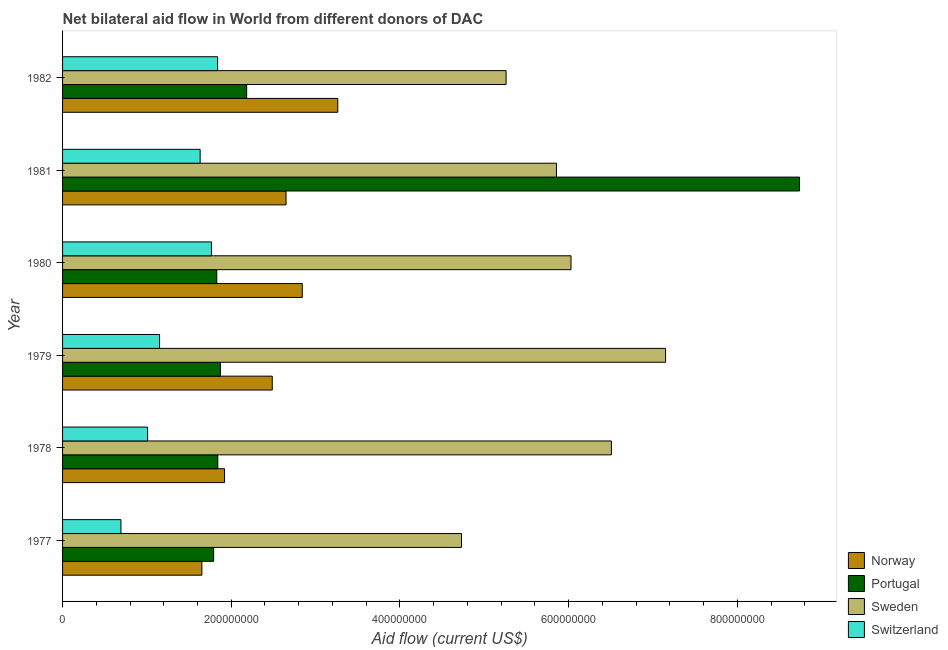How many groups of bars are there?
Ensure brevity in your answer.  6. Are the number of bars per tick equal to the number of legend labels?
Offer a terse response. Yes. Are the number of bars on each tick of the Y-axis equal?
Provide a succinct answer. Yes. How many bars are there on the 3rd tick from the top?
Keep it short and to the point. 4. How many bars are there on the 5th tick from the bottom?
Give a very brief answer. 4. In how many cases, is the number of bars for a given year not equal to the number of legend labels?
Keep it short and to the point. 0. What is the amount of aid given by portugal in 1982?
Offer a very short reply. 2.18e+08. Across all years, what is the maximum amount of aid given by switzerland?
Provide a succinct answer. 1.84e+08. Across all years, what is the minimum amount of aid given by norway?
Your answer should be very brief. 1.65e+08. In which year was the amount of aid given by portugal maximum?
Provide a succinct answer. 1981. What is the total amount of aid given by switzerland in the graph?
Your response must be concise. 8.09e+08. What is the difference between the amount of aid given by switzerland in 1978 and that in 1982?
Offer a very short reply. -8.30e+07. What is the difference between the amount of aid given by norway in 1982 and the amount of aid given by portugal in 1978?
Provide a succinct answer. 1.42e+08. What is the average amount of aid given by sweden per year?
Provide a short and direct response. 5.92e+08. In the year 1982, what is the difference between the amount of aid given by portugal and amount of aid given by norway?
Your response must be concise. -1.08e+08. What is the ratio of the amount of aid given by sweden in 1979 to that in 1980?
Your response must be concise. 1.19. What is the difference between the highest and the second highest amount of aid given by norway?
Ensure brevity in your answer.  4.21e+07. What is the difference between the highest and the lowest amount of aid given by sweden?
Provide a short and direct response. 2.42e+08. In how many years, is the amount of aid given by switzerland greater than the average amount of aid given by switzerland taken over all years?
Your response must be concise. 3. Is the sum of the amount of aid given by portugal in 1980 and 1981 greater than the maximum amount of aid given by sweden across all years?
Your answer should be very brief. Yes. Is it the case that in every year, the sum of the amount of aid given by switzerland and amount of aid given by norway is greater than the sum of amount of aid given by portugal and amount of aid given by sweden?
Offer a terse response. No. What does the 3rd bar from the top in 1977 represents?
Provide a succinct answer. Portugal. What does the 2nd bar from the bottom in 1978 represents?
Provide a short and direct response. Portugal. Is it the case that in every year, the sum of the amount of aid given by norway and amount of aid given by portugal is greater than the amount of aid given by sweden?
Give a very brief answer. No. How many years are there in the graph?
Your response must be concise. 6. What is the difference between two consecutive major ticks on the X-axis?
Your response must be concise. 2.00e+08. Does the graph contain grids?
Give a very brief answer. No. Where does the legend appear in the graph?
Your response must be concise. Bottom right. What is the title of the graph?
Ensure brevity in your answer.  Net bilateral aid flow in World from different donors of DAC. What is the label or title of the X-axis?
Keep it short and to the point. Aid flow (current US$). What is the label or title of the Y-axis?
Keep it short and to the point. Year. What is the Aid flow (current US$) in Norway in 1977?
Your answer should be very brief. 1.65e+08. What is the Aid flow (current US$) in Portugal in 1977?
Offer a terse response. 1.79e+08. What is the Aid flow (current US$) of Sweden in 1977?
Offer a terse response. 4.73e+08. What is the Aid flow (current US$) in Switzerland in 1977?
Offer a very short reply. 6.92e+07. What is the Aid flow (current US$) of Norway in 1978?
Offer a terse response. 1.92e+08. What is the Aid flow (current US$) of Portugal in 1978?
Offer a very short reply. 1.84e+08. What is the Aid flow (current US$) of Sweden in 1978?
Your answer should be very brief. 6.51e+08. What is the Aid flow (current US$) of Switzerland in 1978?
Offer a terse response. 1.01e+08. What is the Aid flow (current US$) in Norway in 1979?
Make the answer very short. 2.49e+08. What is the Aid flow (current US$) in Portugal in 1979?
Give a very brief answer. 1.87e+08. What is the Aid flow (current US$) in Sweden in 1979?
Offer a very short reply. 7.15e+08. What is the Aid flow (current US$) in Switzerland in 1979?
Make the answer very short. 1.15e+08. What is the Aid flow (current US$) of Norway in 1980?
Offer a very short reply. 2.84e+08. What is the Aid flow (current US$) of Portugal in 1980?
Give a very brief answer. 1.83e+08. What is the Aid flow (current US$) in Sweden in 1980?
Your response must be concise. 6.03e+08. What is the Aid flow (current US$) in Switzerland in 1980?
Keep it short and to the point. 1.77e+08. What is the Aid flow (current US$) of Norway in 1981?
Give a very brief answer. 2.65e+08. What is the Aid flow (current US$) of Portugal in 1981?
Offer a very short reply. 8.74e+08. What is the Aid flow (current US$) of Sweden in 1981?
Provide a succinct answer. 5.86e+08. What is the Aid flow (current US$) of Switzerland in 1981?
Offer a very short reply. 1.63e+08. What is the Aid flow (current US$) in Norway in 1982?
Give a very brief answer. 3.26e+08. What is the Aid flow (current US$) of Portugal in 1982?
Your response must be concise. 2.18e+08. What is the Aid flow (current US$) of Sweden in 1982?
Your answer should be very brief. 5.26e+08. What is the Aid flow (current US$) in Switzerland in 1982?
Your answer should be very brief. 1.84e+08. Across all years, what is the maximum Aid flow (current US$) in Norway?
Your answer should be compact. 3.26e+08. Across all years, what is the maximum Aid flow (current US$) in Portugal?
Your response must be concise. 8.74e+08. Across all years, what is the maximum Aid flow (current US$) of Sweden?
Ensure brevity in your answer.  7.15e+08. Across all years, what is the maximum Aid flow (current US$) of Switzerland?
Your answer should be very brief. 1.84e+08. Across all years, what is the minimum Aid flow (current US$) in Norway?
Provide a short and direct response. 1.65e+08. Across all years, what is the minimum Aid flow (current US$) in Portugal?
Provide a succinct answer. 1.79e+08. Across all years, what is the minimum Aid flow (current US$) of Sweden?
Offer a very short reply. 4.73e+08. Across all years, what is the minimum Aid flow (current US$) of Switzerland?
Make the answer very short. 6.92e+07. What is the total Aid flow (current US$) of Norway in the graph?
Your response must be concise. 1.48e+09. What is the total Aid flow (current US$) in Portugal in the graph?
Your answer should be compact. 1.83e+09. What is the total Aid flow (current US$) in Sweden in the graph?
Give a very brief answer. 3.55e+09. What is the total Aid flow (current US$) in Switzerland in the graph?
Keep it short and to the point. 8.09e+08. What is the difference between the Aid flow (current US$) of Norway in 1977 and that in 1978?
Provide a succinct answer. -2.69e+07. What is the difference between the Aid flow (current US$) in Portugal in 1977 and that in 1978?
Make the answer very short. -4.93e+06. What is the difference between the Aid flow (current US$) in Sweden in 1977 and that in 1978?
Offer a terse response. -1.78e+08. What is the difference between the Aid flow (current US$) in Switzerland in 1977 and that in 1978?
Your answer should be very brief. -3.16e+07. What is the difference between the Aid flow (current US$) in Norway in 1977 and that in 1979?
Your answer should be very brief. -8.34e+07. What is the difference between the Aid flow (current US$) in Portugal in 1977 and that in 1979?
Offer a terse response. -8.00e+06. What is the difference between the Aid flow (current US$) in Sweden in 1977 and that in 1979?
Give a very brief answer. -2.42e+08. What is the difference between the Aid flow (current US$) in Switzerland in 1977 and that in 1979?
Ensure brevity in your answer.  -4.58e+07. What is the difference between the Aid flow (current US$) in Norway in 1977 and that in 1980?
Your answer should be very brief. -1.19e+08. What is the difference between the Aid flow (current US$) in Portugal in 1977 and that in 1980?
Provide a succinct answer. -3.70e+06. What is the difference between the Aid flow (current US$) of Sweden in 1977 and that in 1980?
Offer a very short reply. -1.30e+08. What is the difference between the Aid flow (current US$) of Switzerland in 1977 and that in 1980?
Offer a very short reply. -1.07e+08. What is the difference between the Aid flow (current US$) in Norway in 1977 and that in 1981?
Provide a short and direct response. -9.98e+07. What is the difference between the Aid flow (current US$) of Portugal in 1977 and that in 1981?
Offer a terse response. -6.95e+08. What is the difference between the Aid flow (current US$) in Sweden in 1977 and that in 1981?
Your response must be concise. -1.13e+08. What is the difference between the Aid flow (current US$) in Switzerland in 1977 and that in 1981?
Make the answer very short. -9.39e+07. What is the difference between the Aid flow (current US$) of Norway in 1977 and that in 1982?
Offer a terse response. -1.61e+08. What is the difference between the Aid flow (current US$) of Portugal in 1977 and that in 1982?
Ensure brevity in your answer.  -3.92e+07. What is the difference between the Aid flow (current US$) of Sweden in 1977 and that in 1982?
Offer a very short reply. -5.29e+07. What is the difference between the Aid flow (current US$) in Switzerland in 1977 and that in 1982?
Provide a short and direct response. -1.15e+08. What is the difference between the Aid flow (current US$) of Norway in 1978 and that in 1979?
Ensure brevity in your answer.  -5.66e+07. What is the difference between the Aid flow (current US$) in Portugal in 1978 and that in 1979?
Your answer should be very brief. -3.07e+06. What is the difference between the Aid flow (current US$) of Sweden in 1978 and that in 1979?
Ensure brevity in your answer.  -6.43e+07. What is the difference between the Aid flow (current US$) of Switzerland in 1978 and that in 1979?
Your answer should be compact. -1.42e+07. What is the difference between the Aid flow (current US$) in Norway in 1978 and that in 1980?
Your response must be concise. -9.22e+07. What is the difference between the Aid flow (current US$) of Portugal in 1978 and that in 1980?
Offer a terse response. 1.23e+06. What is the difference between the Aid flow (current US$) in Sweden in 1978 and that in 1980?
Your answer should be very brief. 4.79e+07. What is the difference between the Aid flow (current US$) of Switzerland in 1978 and that in 1980?
Your answer should be compact. -7.57e+07. What is the difference between the Aid flow (current US$) in Norway in 1978 and that in 1981?
Keep it short and to the point. -7.29e+07. What is the difference between the Aid flow (current US$) of Portugal in 1978 and that in 1981?
Your answer should be compact. -6.90e+08. What is the difference between the Aid flow (current US$) in Sweden in 1978 and that in 1981?
Give a very brief answer. 6.51e+07. What is the difference between the Aid flow (current US$) in Switzerland in 1978 and that in 1981?
Ensure brevity in your answer.  -6.23e+07. What is the difference between the Aid flow (current US$) of Norway in 1978 and that in 1982?
Offer a very short reply. -1.34e+08. What is the difference between the Aid flow (current US$) in Portugal in 1978 and that in 1982?
Your response must be concise. -3.42e+07. What is the difference between the Aid flow (current US$) in Sweden in 1978 and that in 1982?
Ensure brevity in your answer.  1.25e+08. What is the difference between the Aid flow (current US$) in Switzerland in 1978 and that in 1982?
Give a very brief answer. -8.30e+07. What is the difference between the Aid flow (current US$) of Norway in 1979 and that in 1980?
Offer a terse response. -3.56e+07. What is the difference between the Aid flow (current US$) of Portugal in 1979 and that in 1980?
Make the answer very short. 4.30e+06. What is the difference between the Aid flow (current US$) of Sweden in 1979 and that in 1980?
Provide a succinct answer. 1.12e+08. What is the difference between the Aid flow (current US$) of Switzerland in 1979 and that in 1980?
Ensure brevity in your answer.  -6.15e+07. What is the difference between the Aid flow (current US$) of Norway in 1979 and that in 1981?
Keep it short and to the point. -1.63e+07. What is the difference between the Aid flow (current US$) of Portugal in 1979 and that in 1981?
Offer a very short reply. -6.87e+08. What is the difference between the Aid flow (current US$) of Sweden in 1979 and that in 1981?
Offer a terse response. 1.29e+08. What is the difference between the Aid flow (current US$) of Switzerland in 1979 and that in 1981?
Provide a succinct answer. -4.81e+07. What is the difference between the Aid flow (current US$) of Norway in 1979 and that in 1982?
Offer a terse response. -7.77e+07. What is the difference between the Aid flow (current US$) of Portugal in 1979 and that in 1982?
Provide a short and direct response. -3.12e+07. What is the difference between the Aid flow (current US$) in Sweden in 1979 and that in 1982?
Ensure brevity in your answer.  1.89e+08. What is the difference between the Aid flow (current US$) of Switzerland in 1979 and that in 1982?
Offer a terse response. -6.88e+07. What is the difference between the Aid flow (current US$) of Norway in 1980 and that in 1981?
Provide a succinct answer. 1.93e+07. What is the difference between the Aid flow (current US$) in Portugal in 1980 and that in 1981?
Provide a succinct answer. -6.91e+08. What is the difference between the Aid flow (current US$) in Sweden in 1980 and that in 1981?
Ensure brevity in your answer.  1.72e+07. What is the difference between the Aid flow (current US$) in Switzerland in 1980 and that in 1981?
Offer a terse response. 1.34e+07. What is the difference between the Aid flow (current US$) in Norway in 1980 and that in 1982?
Ensure brevity in your answer.  -4.21e+07. What is the difference between the Aid flow (current US$) of Portugal in 1980 and that in 1982?
Make the answer very short. -3.54e+07. What is the difference between the Aid flow (current US$) in Sweden in 1980 and that in 1982?
Your answer should be compact. 7.70e+07. What is the difference between the Aid flow (current US$) in Switzerland in 1980 and that in 1982?
Your answer should be very brief. -7.31e+06. What is the difference between the Aid flow (current US$) in Norway in 1981 and that in 1982?
Offer a very short reply. -6.13e+07. What is the difference between the Aid flow (current US$) of Portugal in 1981 and that in 1982?
Your response must be concise. 6.56e+08. What is the difference between the Aid flow (current US$) in Sweden in 1981 and that in 1982?
Your answer should be very brief. 5.97e+07. What is the difference between the Aid flow (current US$) in Switzerland in 1981 and that in 1982?
Make the answer very short. -2.07e+07. What is the difference between the Aid flow (current US$) in Norway in 1977 and the Aid flow (current US$) in Portugal in 1978?
Your answer should be compact. -1.89e+07. What is the difference between the Aid flow (current US$) of Norway in 1977 and the Aid flow (current US$) of Sweden in 1978?
Your response must be concise. -4.86e+08. What is the difference between the Aid flow (current US$) in Norway in 1977 and the Aid flow (current US$) in Switzerland in 1978?
Your answer should be very brief. 6.44e+07. What is the difference between the Aid flow (current US$) of Portugal in 1977 and the Aid flow (current US$) of Sweden in 1978?
Offer a terse response. -4.72e+08. What is the difference between the Aid flow (current US$) in Portugal in 1977 and the Aid flow (current US$) in Switzerland in 1978?
Make the answer very short. 7.83e+07. What is the difference between the Aid flow (current US$) of Sweden in 1977 and the Aid flow (current US$) of Switzerland in 1978?
Offer a very short reply. 3.72e+08. What is the difference between the Aid flow (current US$) of Norway in 1977 and the Aid flow (current US$) of Portugal in 1979?
Ensure brevity in your answer.  -2.20e+07. What is the difference between the Aid flow (current US$) in Norway in 1977 and the Aid flow (current US$) in Sweden in 1979?
Offer a terse response. -5.50e+08. What is the difference between the Aid flow (current US$) in Norway in 1977 and the Aid flow (current US$) in Switzerland in 1979?
Your answer should be compact. 5.02e+07. What is the difference between the Aid flow (current US$) in Portugal in 1977 and the Aid flow (current US$) in Sweden in 1979?
Keep it short and to the point. -5.36e+08. What is the difference between the Aid flow (current US$) of Portugal in 1977 and the Aid flow (current US$) of Switzerland in 1979?
Your response must be concise. 6.41e+07. What is the difference between the Aid flow (current US$) in Sweden in 1977 and the Aid flow (current US$) in Switzerland in 1979?
Provide a succinct answer. 3.58e+08. What is the difference between the Aid flow (current US$) of Norway in 1977 and the Aid flow (current US$) of Portugal in 1980?
Provide a succinct answer. -1.76e+07. What is the difference between the Aid flow (current US$) in Norway in 1977 and the Aid flow (current US$) in Sweden in 1980?
Provide a succinct answer. -4.38e+08. What is the difference between the Aid flow (current US$) of Norway in 1977 and the Aid flow (current US$) of Switzerland in 1980?
Your answer should be compact. -1.13e+07. What is the difference between the Aid flow (current US$) of Portugal in 1977 and the Aid flow (current US$) of Sweden in 1980?
Ensure brevity in your answer.  -4.24e+08. What is the difference between the Aid flow (current US$) of Portugal in 1977 and the Aid flow (current US$) of Switzerland in 1980?
Ensure brevity in your answer.  2.63e+06. What is the difference between the Aid flow (current US$) of Sweden in 1977 and the Aid flow (current US$) of Switzerland in 1980?
Provide a succinct answer. 2.97e+08. What is the difference between the Aid flow (current US$) of Norway in 1977 and the Aid flow (current US$) of Portugal in 1981?
Your answer should be very brief. -7.09e+08. What is the difference between the Aid flow (current US$) in Norway in 1977 and the Aid flow (current US$) in Sweden in 1981?
Provide a short and direct response. -4.20e+08. What is the difference between the Aid flow (current US$) of Norway in 1977 and the Aid flow (current US$) of Switzerland in 1981?
Your answer should be very brief. 2.07e+06. What is the difference between the Aid flow (current US$) in Portugal in 1977 and the Aid flow (current US$) in Sweden in 1981?
Make the answer very short. -4.06e+08. What is the difference between the Aid flow (current US$) in Portugal in 1977 and the Aid flow (current US$) in Switzerland in 1981?
Make the answer very short. 1.60e+07. What is the difference between the Aid flow (current US$) in Sweden in 1977 and the Aid flow (current US$) in Switzerland in 1981?
Ensure brevity in your answer.  3.10e+08. What is the difference between the Aid flow (current US$) of Norway in 1977 and the Aid flow (current US$) of Portugal in 1982?
Ensure brevity in your answer.  -5.31e+07. What is the difference between the Aid flow (current US$) of Norway in 1977 and the Aid flow (current US$) of Sweden in 1982?
Offer a very short reply. -3.61e+08. What is the difference between the Aid flow (current US$) of Norway in 1977 and the Aid flow (current US$) of Switzerland in 1982?
Make the answer very short. -1.86e+07. What is the difference between the Aid flow (current US$) of Portugal in 1977 and the Aid flow (current US$) of Sweden in 1982?
Provide a succinct answer. -3.47e+08. What is the difference between the Aid flow (current US$) of Portugal in 1977 and the Aid flow (current US$) of Switzerland in 1982?
Your response must be concise. -4.68e+06. What is the difference between the Aid flow (current US$) of Sweden in 1977 and the Aid flow (current US$) of Switzerland in 1982?
Provide a short and direct response. 2.89e+08. What is the difference between the Aid flow (current US$) of Norway in 1978 and the Aid flow (current US$) of Portugal in 1979?
Your answer should be very brief. 4.91e+06. What is the difference between the Aid flow (current US$) in Norway in 1978 and the Aid flow (current US$) in Sweden in 1979?
Your response must be concise. -5.23e+08. What is the difference between the Aid flow (current US$) in Norway in 1978 and the Aid flow (current US$) in Switzerland in 1979?
Provide a short and direct response. 7.70e+07. What is the difference between the Aid flow (current US$) of Portugal in 1978 and the Aid flow (current US$) of Sweden in 1979?
Provide a succinct answer. -5.31e+08. What is the difference between the Aid flow (current US$) of Portugal in 1978 and the Aid flow (current US$) of Switzerland in 1979?
Give a very brief answer. 6.90e+07. What is the difference between the Aid flow (current US$) in Sweden in 1978 and the Aid flow (current US$) in Switzerland in 1979?
Your answer should be compact. 5.36e+08. What is the difference between the Aid flow (current US$) in Norway in 1978 and the Aid flow (current US$) in Portugal in 1980?
Ensure brevity in your answer.  9.21e+06. What is the difference between the Aid flow (current US$) of Norway in 1978 and the Aid flow (current US$) of Sweden in 1980?
Ensure brevity in your answer.  -4.11e+08. What is the difference between the Aid flow (current US$) in Norway in 1978 and the Aid flow (current US$) in Switzerland in 1980?
Give a very brief answer. 1.55e+07. What is the difference between the Aid flow (current US$) in Portugal in 1978 and the Aid flow (current US$) in Sweden in 1980?
Offer a terse response. -4.19e+08. What is the difference between the Aid flow (current US$) in Portugal in 1978 and the Aid flow (current US$) in Switzerland in 1980?
Offer a very short reply. 7.56e+06. What is the difference between the Aid flow (current US$) of Sweden in 1978 and the Aid flow (current US$) of Switzerland in 1980?
Give a very brief answer. 4.74e+08. What is the difference between the Aid flow (current US$) of Norway in 1978 and the Aid flow (current US$) of Portugal in 1981?
Your response must be concise. -6.82e+08. What is the difference between the Aid flow (current US$) of Norway in 1978 and the Aid flow (current US$) of Sweden in 1981?
Offer a terse response. -3.94e+08. What is the difference between the Aid flow (current US$) of Norway in 1978 and the Aid flow (current US$) of Switzerland in 1981?
Your answer should be compact. 2.89e+07. What is the difference between the Aid flow (current US$) of Portugal in 1978 and the Aid flow (current US$) of Sweden in 1981?
Ensure brevity in your answer.  -4.02e+08. What is the difference between the Aid flow (current US$) in Portugal in 1978 and the Aid flow (current US$) in Switzerland in 1981?
Your answer should be very brief. 2.10e+07. What is the difference between the Aid flow (current US$) in Sweden in 1978 and the Aid flow (current US$) in Switzerland in 1981?
Provide a succinct answer. 4.88e+08. What is the difference between the Aid flow (current US$) of Norway in 1978 and the Aid flow (current US$) of Portugal in 1982?
Offer a very short reply. -2.62e+07. What is the difference between the Aid flow (current US$) of Norway in 1978 and the Aid flow (current US$) of Sweden in 1982?
Keep it short and to the point. -3.34e+08. What is the difference between the Aid flow (current US$) in Norway in 1978 and the Aid flow (current US$) in Switzerland in 1982?
Make the answer very short. 8.23e+06. What is the difference between the Aid flow (current US$) in Portugal in 1978 and the Aid flow (current US$) in Sweden in 1982?
Offer a terse response. -3.42e+08. What is the difference between the Aid flow (current US$) in Portugal in 1978 and the Aid flow (current US$) in Switzerland in 1982?
Provide a short and direct response. 2.50e+05. What is the difference between the Aid flow (current US$) of Sweden in 1978 and the Aid flow (current US$) of Switzerland in 1982?
Provide a succinct answer. 4.67e+08. What is the difference between the Aid flow (current US$) in Norway in 1979 and the Aid flow (current US$) in Portugal in 1980?
Offer a very short reply. 6.58e+07. What is the difference between the Aid flow (current US$) of Norway in 1979 and the Aid flow (current US$) of Sweden in 1980?
Your answer should be compact. -3.54e+08. What is the difference between the Aid flow (current US$) in Norway in 1979 and the Aid flow (current US$) in Switzerland in 1980?
Offer a very short reply. 7.21e+07. What is the difference between the Aid flow (current US$) in Portugal in 1979 and the Aid flow (current US$) in Sweden in 1980?
Offer a very short reply. -4.16e+08. What is the difference between the Aid flow (current US$) in Portugal in 1979 and the Aid flow (current US$) in Switzerland in 1980?
Give a very brief answer. 1.06e+07. What is the difference between the Aid flow (current US$) of Sweden in 1979 and the Aid flow (current US$) of Switzerland in 1980?
Give a very brief answer. 5.38e+08. What is the difference between the Aid flow (current US$) of Norway in 1979 and the Aid flow (current US$) of Portugal in 1981?
Provide a short and direct response. -6.25e+08. What is the difference between the Aid flow (current US$) in Norway in 1979 and the Aid flow (current US$) in Sweden in 1981?
Provide a short and direct response. -3.37e+08. What is the difference between the Aid flow (current US$) of Norway in 1979 and the Aid flow (current US$) of Switzerland in 1981?
Keep it short and to the point. 8.55e+07. What is the difference between the Aid flow (current US$) in Portugal in 1979 and the Aid flow (current US$) in Sweden in 1981?
Provide a succinct answer. -3.98e+08. What is the difference between the Aid flow (current US$) of Portugal in 1979 and the Aid flow (current US$) of Switzerland in 1981?
Offer a very short reply. 2.40e+07. What is the difference between the Aid flow (current US$) of Sweden in 1979 and the Aid flow (current US$) of Switzerland in 1981?
Offer a very short reply. 5.52e+08. What is the difference between the Aid flow (current US$) in Norway in 1979 and the Aid flow (current US$) in Portugal in 1982?
Offer a terse response. 3.03e+07. What is the difference between the Aid flow (current US$) in Norway in 1979 and the Aid flow (current US$) in Sweden in 1982?
Provide a succinct answer. -2.77e+08. What is the difference between the Aid flow (current US$) in Norway in 1979 and the Aid flow (current US$) in Switzerland in 1982?
Ensure brevity in your answer.  6.48e+07. What is the difference between the Aid flow (current US$) of Portugal in 1979 and the Aid flow (current US$) of Sweden in 1982?
Give a very brief answer. -3.39e+08. What is the difference between the Aid flow (current US$) in Portugal in 1979 and the Aid flow (current US$) in Switzerland in 1982?
Offer a very short reply. 3.32e+06. What is the difference between the Aid flow (current US$) in Sweden in 1979 and the Aid flow (current US$) in Switzerland in 1982?
Ensure brevity in your answer.  5.31e+08. What is the difference between the Aid flow (current US$) in Norway in 1980 and the Aid flow (current US$) in Portugal in 1981?
Ensure brevity in your answer.  -5.90e+08. What is the difference between the Aid flow (current US$) of Norway in 1980 and the Aid flow (current US$) of Sweden in 1981?
Offer a very short reply. -3.01e+08. What is the difference between the Aid flow (current US$) in Norway in 1980 and the Aid flow (current US$) in Switzerland in 1981?
Offer a terse response. 1.21e+08. What is the difference between the Aid flow (current US$) in Portugal in 1980 and the Aid flow (current US$) in Sweden in 1981?
Your response must be concise. -4.03e+08. What is the difference between the Aid flow (current US$) of Portugal in 1980 and the Aid flow (current US$) of Switzerland in 1981?
Your answer should be compact. 1.97e+07. What is the difference between the Aid flow (current US$) in Sweden in 1980 and the Aid flow (current US$) in Switzerland in 1981?
Make the answer very short. 4.40e+08. What is the difference between the Aid flow (current US$) in Norway in 1980 and the Aid flow (current US$) in Portugal in 1982?
Your answer should be very brief. 6.60e+07. What is the difference between the Aid flow (current US$) in Norway in 1980 and the Aid flow (current US$) in Sweden in 1982?
Provide a short and direct response. -2.42e+08. What is the difference between the Aid flow (current US$) of Norway in 1980 and the Aid flow (current US$) of Switzerland in 1982?
Give a very brief answer. 1.00e+08. What is the difference between the Aid flow (current US$) in Portugal in 1980 and the Aid flow (current US$) in Sweden in 1982?
Offer a terse response. -3.43e+08. What is the difference between the Aid flow (current US$) in Portugal in 1980 and the Aid flow (current US$) in Switzerland in 1982?
Offer a terse response. -9.80e+05. What is the difference between the Aid flow (current US$) in Sweden in 1980 and the Aid flow (current US$) in Switzerland in 1982?
Keep it short and to the point. 4.19e+08. What is the difference between the Aid flow (current US$) in Norway in 1981 and the Aid flow (current US$) in Portugal in 1982?
Offer a very short reply. 4.67e+07. What is the difference between the Aid flow (current US$) in Norway in 1981 and the Aid flow (current US$) in Sweden in 1982?
Your response must be concise. -2.61e+08. What is the difference between the Aid flow (current US$) of Norway in 1981 and the Aid flow (current US$) of Switzerland in 1982?
Your response must be concise. 8.12e+07. What is the difference between the Aid flow (current US$) of Portugal in 1981 and the Aid flow (current US$) of Sweden in 1982?
Provide a succinct answer. 3.48e+08. What is the difference between the Aid flow (current US$) of Portugal in 1981 and the Aid flow (current US$) of Switzerland in 1982?
Give a very brief answer. 6.90e+08. What is the difference between the Aid flow (current US$) in Sweden in 1981 and the Aid flow (current US$) in Switzerland in 1982?
Your answer should be very brief. 4.02e+08. What is the average Aid flow (current US$) in Norway per year?
Offer a terse response. 2.47e+08. What is the average Aid flow (current US$) in Portugal per year?
Offer a terse response. 3.04e+08. What is the average Aid flow (current US$) of Sweden per year?
Give a very brief answer. 5.92e+08. What is the average Aid flow (current US$) in Switzerland per year?
Make the answer very short. 1.35e+08. In the year 1977, what is the difference between the Aid flow (current US$) of Norway and Aid flow (current US$) of Portugal?
Your answer should be very brief. -1.40e+07. In the year 1977, what is the difference between the Aid flow (current US$) in Norway and Aid flow (current US$) in Sweden?
Your answer should be very brief. -3.08e+08. In the year 1977, what is the difference between the Aid flow (current US$) in Norway and Aid flow (current US$) in Switzerland?
Keep it short and to the point. 9.60e+07. In the year 1977, what is the difference between the Aid flow (current US$) of Portugal and Aid flow (current US$) of Sweden?
Your answer should be compact. -2.94e+08. In the year 1977, what is the difference between the Aid flow (current US$) of Portugal and Aid flow (current US$) of Switzerland?
Keep it short and to the point. 1.10e+08. In the year 1977, what is the difference between the Aid flow (current US$) in Sweden and Aid flow (current US$) in Switzerland?
Your answer should be very brief. 4.04e+08. In the year 1978, what is the difference between the Aid flow (current US$) of Norway and Aid flow (current US$) of Portugal?
Provide a short and direct response. 7.98e+06. In the year 1978, what is the difference between the Aid flow (current US$) of Norway and Aid flow (current US$) of Sweden?
Offer a very short reply. -4.59e+08. In the year 1978, what is the difference between the Aid flow (current US$) of Norway and Aid flow (current US$) of Switzerland?
Ensure brevity in your answer.  9.12e+07. In the year 1978, what is the difference between the Aid flow (current US$) of Portugal and Aid flow (current US$) of Sweden?
Keep it short and to the point. -4.67e+08. In the year 1978, what is the difference between the Aid flow (current US$) in Portugal and Aid flow (current US$) in Switzerland?
Give a very brief answer. 8.32e+07. In the year 1978, what is the difference between the Aid flow (current US$) of Sweden and Aid flow (current US$) of Switzerland?
Ensure brevity in your answer.  5.50e+08. In the year 1979, what is the difference between the Aid flow (current US$) of Norway and Aid flow (current US$) of Portugal?
Give a very brief answer. 6.15e+07. In the year 1979, what is the difference between the Aid flow (current US$) in Norway and Aid flow (current US$) in Sweden?
Provide a succinct answer. -4.66e+08. In the year 1979, what is the difference between the Aid flow (current US$) in Norway and Aid flow (current US$) in Switzerland?
Provide a succinct answer. 1.34e+08. In the year 1979, what is the difference between the Aid flow (current US$) in Portugal and Aid flow (current US$) in Sweden?
Give a very brief answer. -5.28e+08. In the year 1979, what is the difference between the Aid flow (current US$) of Portugal and Aid flow (current US$) of Switzerland?
Provide a short and direct response. 7.21e+07. In the year 1979, what is the difference between the Aid flow (current US$) in Sweden and Aid flow (current US$) in Switzerland?
Provide a succinct answer. 6.00e+08. In the year 1980, what is the difference between the Aid flow (current US$) of Norway and Aid flow (current US$) of Portugal?
Your answer should be compact. 1.01e+08. In the year 1980, what is the difference between the Aid flow (current US$) of Norway and Aid flow (current US$) of Sweden?
Your answer should be very brief. -3.19e+08. In the year 1980, what is the difference between the Aid flow (current US$) in Norway and Aid flow (current US$) in Switzerland?
Your answer should be very brief. 1.08e+08. In the year 1980, what is the difference between the Aid flow (current US$) of Portugal and Aid flow (current US$) of Sweden?
Provide a short and direct response. -4.20e+08. In the year 1980, what is the difference between the Aid flow (current US$) in Portugal and Aid flow (current US$) in Switzerland?
Offer a very short reply. 6.33e+06. In the year 1980, what is the difference between the Aid flow (current US$) of Sweden and Aid flow (current US$) of Switzerland?
Your response must be concise. 4.26e+08. In the year 1981, what is the difference between the Aid flow (current US$) of Norway and Aid flow (current US$) of Portugal?
Your answer should be compact. -6.09e+08. In the year 1981, what is the difference between the Aid flow (current US$) in Norway and Aid flow (current US$) in Sweden?
Your answer should be very brief. -3.21e+08. In the year 1981, what is the difference between the Aid flow (current US$) of Norway and Aid flow (current US$) of Switzerland?
Your answer should be very brief. 1.02e+08. In the year 1981, what is the difference between the Aid flow (current US$) in Portugal and Aid flow (current US$) in Sweden?
Offer a very short reply. 2.88e+08. In the year 1981, what is the difference between the Aid flow (current US$) of Portugal and Aid flow (current US$) of Switzerland?
Provide a succinct answer. 7.11e+08. In the year 1981, what is the difference between the Aid flow (current US$) in Sweden and Aid flow (current US$) in Switzerland?
Ensure brevity in your answer.  4.22e+08. In the year 1982, what is the difference between the Aid flow (current US$) of Norway and Aid flow (current US$) of Portugal?
Provide a short and direct response. 1.08e+08. In the year 1982, what is the difference between the Aid flow (current US$) in Norway and Aid flow (current US$) in Sweden?
Make the answer very short. -2.00e+08. In the year 1982, what is the difference between the Aid flow (current US$) in Norway and Aid flow (current US$) in Switzerland?
Offer a terse response. 1.42e+08. In the year 1982, what is the difference between the Aid flow (current US$) of Portugal and Aid flow (current US$) of Sweden?
Ensure brevity in your answer.  -3.08e+08. In the year 1982, what is the difference between the Aid flow (current US$) of Portugal and Aid flow (current US$) of Switzerland?
Give a very brief answer. 3.45e+07. In the year 1982, what is the difference between the Aid flow (current US$) of Sweden and Aid flow (current US$) of Switzerland?
Offer a very short reply. 3.42e+08. What is the ratio of the Aid flow (current US$) of Norway in 1977 to that in 1978?
Offer a terse response. 0.86. What is the ratio of the Aid flow (current US$) of Portugal in 1977 to that in 1978?
Your response must be concise. 0.97. What is the ratio of the Aid flow (current US$) in Sweden in 1977 to that in 1978?
Make the answer very short. 0.73. What is the ratio of the Aid flow (current US$) in Switzerland in 1977 to that in 1978?
Give a very brief answer. 0.69. What is the ratio of the Aid flow (current US$) of Norway in 1977 to that in 1979?
Make the answer very short. 0.66. What is the ratio of the Aid flow (current US$) of Portugal in 1977 to that in 1979?
Give a very brief answer. 0.96. What is the ratio of the Aid flow (current US$) of Sweden in 1977 to that in 1979?
Provide a succinct answer. 0.66. What is the ratio of the Aid flow (current US$) in Switzerland in 1977 to that in 1979?
Your response must be concise. 0.6. What is the ratio of the Aid flow (current US$) in Norway in 1977 to that in 1980?
Your answer should be compact. 0.58. What is the ratio of the Aid flow (current US$) of Portugal in 1977 to that in 1980?
Make the answer very short. 0.98. What is the ratio of the Aid flow (current US$) in Sweden in 1977 to that in 1980?
Make the answer very short. 0.78. What is the ratio of the Aid flow (current US$) in Switzerland in 1977 to that in 1980?
Make the answer very short. 0.39. What is the ratio of the Aid flow (current US$) in Norway in 1977 to that in 1981?
Offer a terse response. 0.62. What is the ratio of the Aid flow (current US$) of Portugal in 1977 to that in 1981?
Keep it short and to the point. 0.2. What is the ratio of the Aid flow (current US$) in Sweden in 1977 to that in 1981?
Your answer should be very brief. 0.81. What is the ratio of the Aid flow (current US$) in Switzerland in 1977 to that in 1981?
Provide a succinct answer. 0.42. What is the ratio of the Aid flow (current US$) in Norway in 1977 to that in 1982?
Offer a very short reply. 0.51. What is the ratio of the Aid flow (current US$) in Portugal in 1977 to that in 1982?
Provide a short and direct response. 0.82. What is the ratio of the Aid flow (current US$) of Sweden in 1977 to that in 1982?
Make the answer very short. 0.9. What is the ratio of the Aid flow (current US$) in Switzerland in 1977 to that in 1982?
Provide a short and direct response. 0.38. What is the ratio of the Aid flow (current US$) of Norway in 1978 to that in 1979?
Offer a very short reply. 0.77. What is the ratio of the Aid flow (current US$) of Portugal in 1978 to that in 1979?
Your answer should be compact. 0.98. What is the ratio of the Aid flow (current US$) of Sweden in 1978 to that in 1979?
Offer a very short reply. 0.91. What is the ratio of the Aid flow (current US$) in Switzerland in 1978 to that in 1979?
Your answer should be very brief. 0.88. What is the ratio of the Aid flow (current US$) of Norway in 1978 to that in 1980?
Make the answer very short. 0.68. What is the ratio of the Aid flow (current US$) of Sweden in 1978 to that in 1980?
Your answer should be very brief. 1.08. What is the ratio of the Aid flow (current US$) of Switzerland in 1978 to that in 1980?
Provide a short and direct response. 0.57. What is the ratio of the Aid flow (current US$) in Norway in 1978 to that in 1981?
Ensure brevity in your answer.  0.72. What is the ratio of the Aid flow (current US$) in Portugal in 1978 to that in 1981?
Your response must be concise. 0.21. What is the ratio of the Aid flow (current US$) of Sweden in 1978 to that in 1981?
Your answer should be very brief. 1.11. What is the ratio of the Aid flow (current US$) of Switzerland in 1978 to that in 1981?
Give a very brief answer. 0.62. What is the ratio of the Aid flow (current US$) of Norway in 1978 to that in 1982?
Your response must be concise. 0.59. What is the ratio of the Aid flow (current US$) of Portugal in 1978 to that in 1982?
Your answer should be compact. 0.84. What is the ratio of the Aid flow (current US$) in Sweden in 1978 to that in 1982?
Your answer should be compact. 1.24. What is the ratio of the Aid flow (current US$) of Switzerland in 1978 to that in 1982?
Ensure brevity in your answer.  0.55. What is the ratio of the Aid flow (current US$) in Norway in 1979 to that in 1980?
Ensure brevity in your answer.  0.87. What is the ratio of the Aid flow (current US$) in Portugal in 1979 to that in 1980?
Keep it short and to the point. 1.02. What is the ratio of the Aid flow (current US$) in Sweden in 1979 to that in 1980?
Make the answer very short. 1.19. What is the ratio of the Aid flow (current US$) of Switzerland in 1979 to that in 1980?
Keep it short and to the point. 0.65. What is the ratio of the Aid flow (current US$) of Norway in 1979 to that in 1981?
Your answer should be compact. 0.94. What is the ratio of the Aid flow (current US$) of Portugal in 1979 to that in 1981?
Give a very brief answer. 0.21. What is the ratio of the Aid flow (current US$) of Sweden in 1979 to that in 1981?
Keep it short and to the point. 1.22. What is the ratio of the Aid flow (current US$) of Switzerland in 1979 to that in 1981?
Keep it short and to the point. 0.71. What is the ratio of the Aid flow (current US$) of Norway in 1979 to that in 1982?
Provide a short and direct response. 0.76. What is the ratio of the Aid flow (current US$) in Portugal in 1979 to that in 1982?
Make the answer very short. 0.86. What is the ratio of the Aid flow (current US$) of Sweden in 1979 to that in 1982?
Offer a terse response. 1.36. What is the ratio of the Aid flow (current US$) of Switzerland in 1979 to that in 1982?
Keep it short and to the point. 0.63. What is the ratio of the Aid flow (current US$) in Norway in 1980 to that in 1981?
Provide a succinct answer. 1.07. What is the ratio of the Aid flow (current US$) in Portugal in 1980 to that in 1981?
Give a very brief answer. 0.21. What is the ratio of the Aid flow (current US$) in Sweden in 1980 to that in 1981?
Give a very brief answer. 1.03. What is the ratio of the Aid flow (current US$) of Switzerland in 1980 to that in 1981?
Your response must be concise. 1.08. What is the ratio of the Aid flow (current US$) in Norway in 1980 to that in 1982?
Provide a succinct answer. 0.87. What is the ratio of the Aid flow (current US$) in Portugal in 1980 to that in 1982?
Provide a short and direct response. 0.84. What is the ratio of the Aid flow (current US$) of Sweden in 1980 to that in 1982?
Your response must be concise. 1.15. What is the ratio of the Aid flow (current US$) in Switzerland in 1980 to that in 1982?
Keep it short and to the point. 0.96. What is the ratio of the Aid flow (current US$) in Norway in 1981 to that in 1982?
Your answer should be compact. 0.81. What is the ratio of the Aid flow (current US$) in Portugal in 1981 to that in 1982?
Keep it short and to the point. 4. What is the ratio of the Aid flow (current US$) in Sweden in 1981 to that in 1982?
Make the answer very short. 1.11. What is the ratio of the Aid flow (current US$) of Switzerland in 1981 to that in 1982?
Keep it short and to the point. 0.89. What is the difference between the highest and the second highest Aid flow (current US$) of Norway?
Your answer should be very brief. 4.21e+07. What is the difference between the highest and the second highest Aid flow (current US$) in Portugal?
Provide a succinct answer. 6.56e+08. What is the difference between the highest and the second highest Aid flow (current US$) of Sweden?
Provide a succinct answer. 6.43e+07. What is the difference between the highest and the second highest Aid flow (current US$) of Switzerland?
Offer a very short reply. 7.31e+06. What is the difference between the highest and the lowest Aid flow (current US$) of Norway?
Keep it short and to the point. 1.61e+08. What is the difference between the highest and the lowest Aid flow (current US$) in Portugal?
Keep it short and to the point. 6.95e+08. What is the difference between the highest and the lowest Aid flow (current US$) in Sweden?
Give a very brief answer. 2.42e+08. What is the difference between the highest and the lowest Aid flow (current US$) in Switzerland?
Provide a succinct answer. 1.15e+08. 